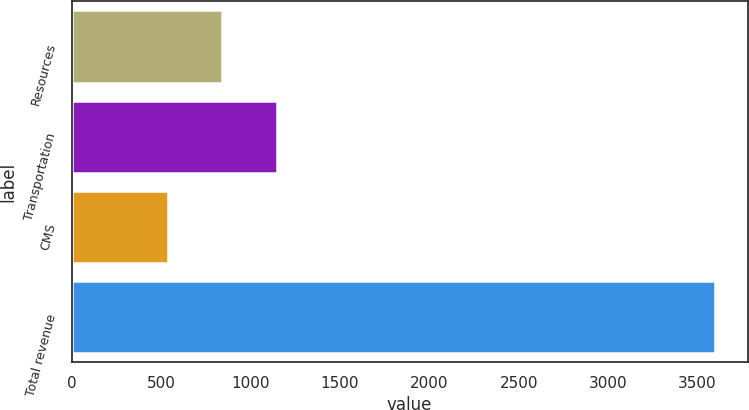Convert chart. <chart><loc_0><loc_0><loc_500><loc_500><bar_chart><fcel>Resources<fcel>Transportation<fcel>CMS<fcel>Total revenue<nl><fcel>842.28<fcel>1148.66<fcel>535.9<fcel>3599.7<nl></chart> 